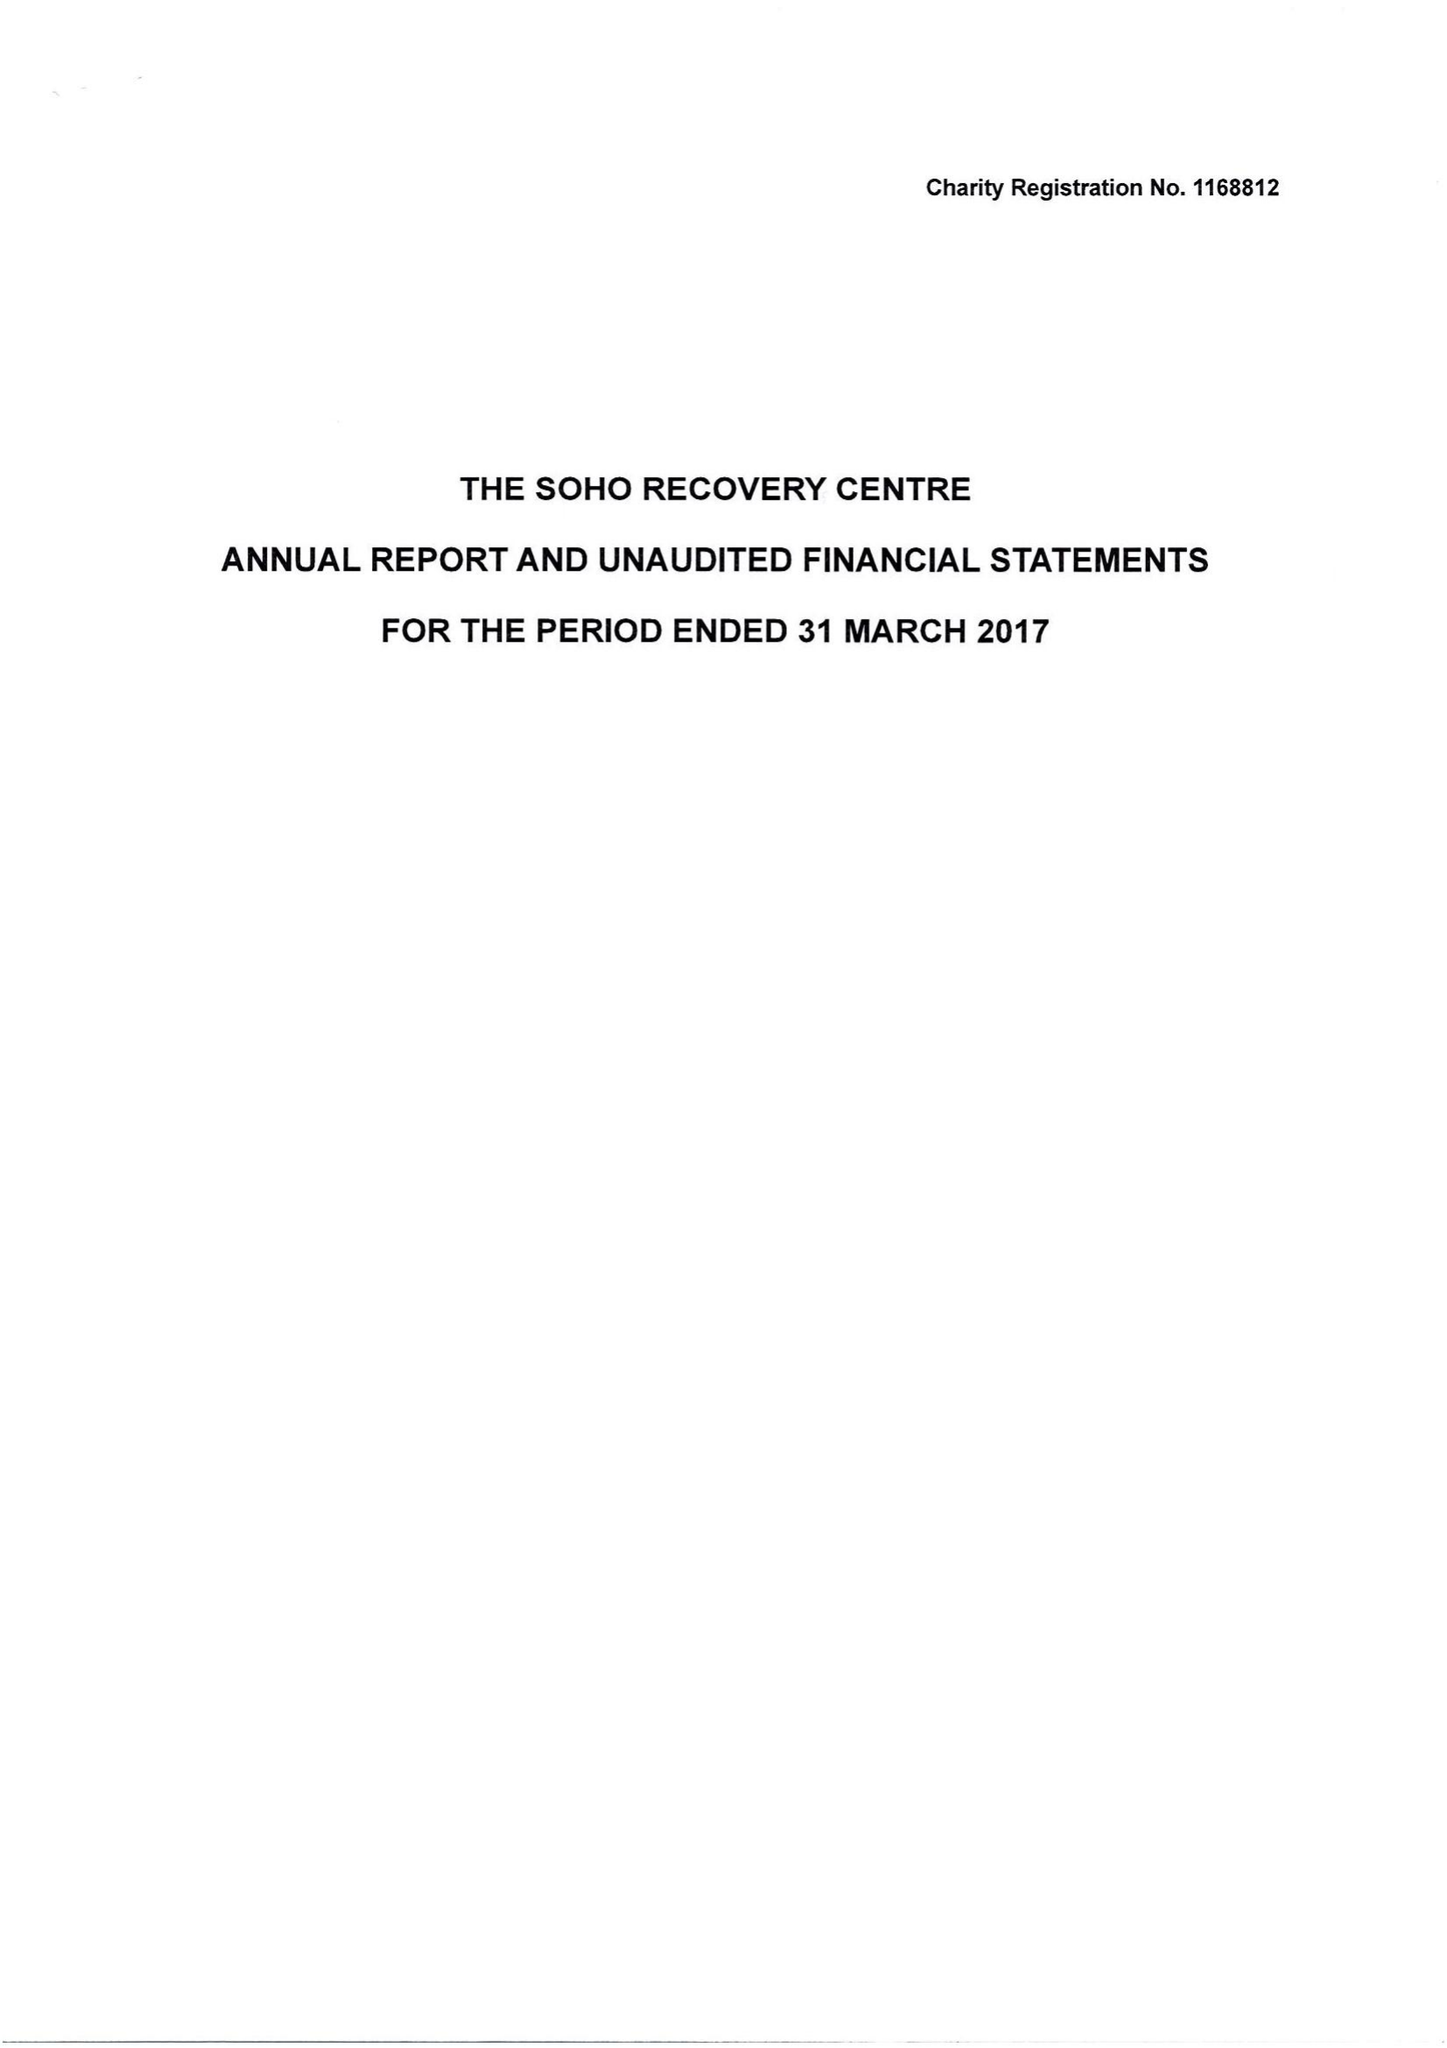What is the value for the address__post_town?
Answer the question using a single word or phrase. LONDON 